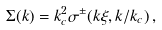<formula> <loc_0><loc_0><loc_500><loc_500>\Sigma ( k ) = k _ { c } ^ { 2 } \sigma ^ { \pm } ( k \xi , k / k _ { c } ) \, ,</formula> 